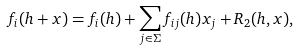<formula> <loc_0><loc_0><loc_500><loc_500>f _ { i } ( h + x ) = f _ { i } ( h ) + \sum _ { j \in \Sigma } f _ { i j } ( h ) x _ { j } + R _ { 2 } ( h , x ) ,</formula> 